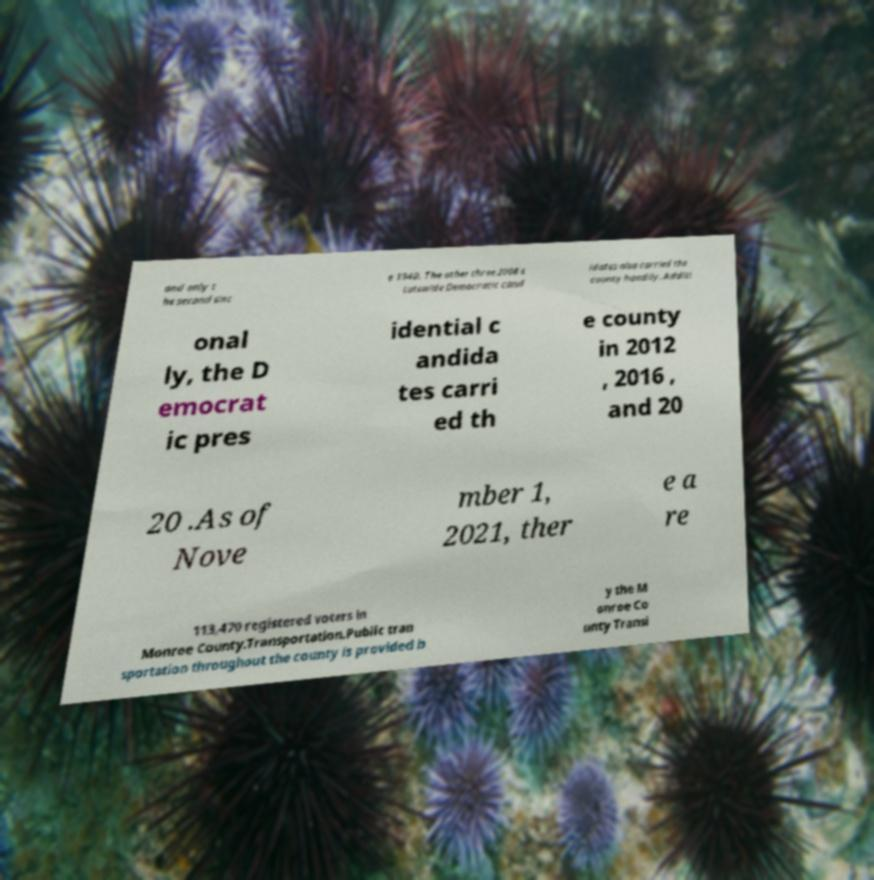I need the written content from this picture converted into text. Can you do that? and only t he second sinc e 1940. The other three 2008 s tatewide Democratic cand idates also carried the county handily. Additi onal ly, the D emocrat ic pres idential c andida tes carri ed th e county in 2012 , 2016 , and 20 20 .As of Nove mber 1, 2021, ther e a re 113,470 registered voters in Monroe County.Transportation.Public tran sportation throughout the county is provided b y the M onroe Co unty Transi 